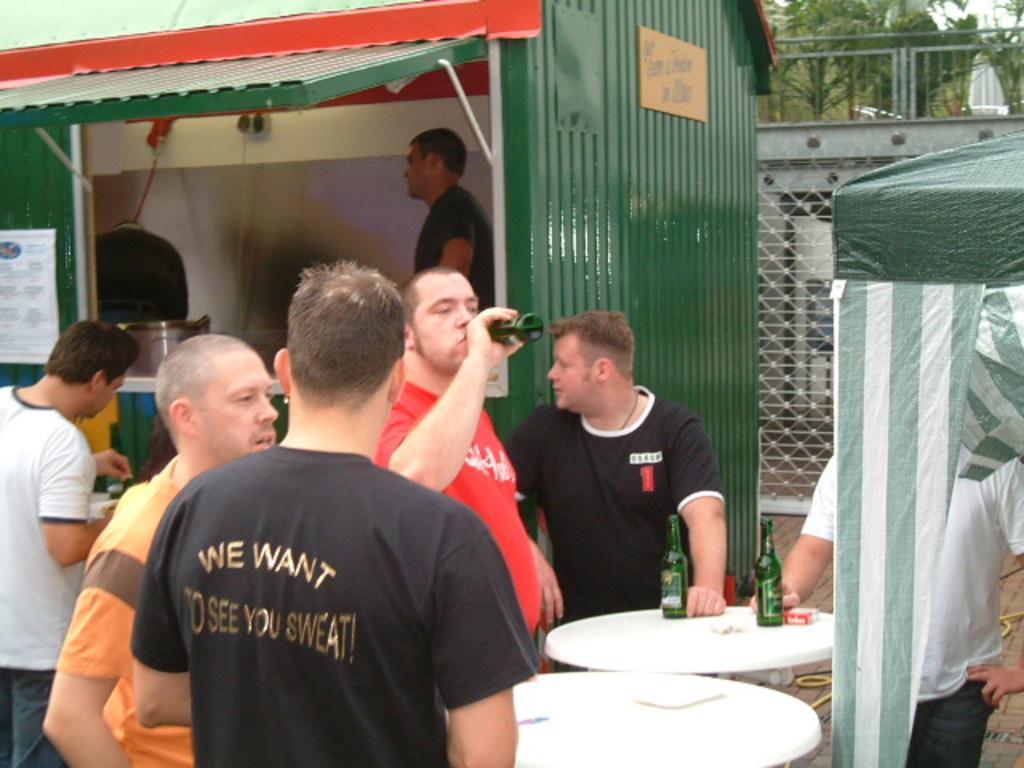How would you summarize this image in a sentence or two? In this image we can see a food truck, persons standing on the floor and tables are placed in front of them. On the tables we can see beverage bottles. In the background there are grills and trees. 